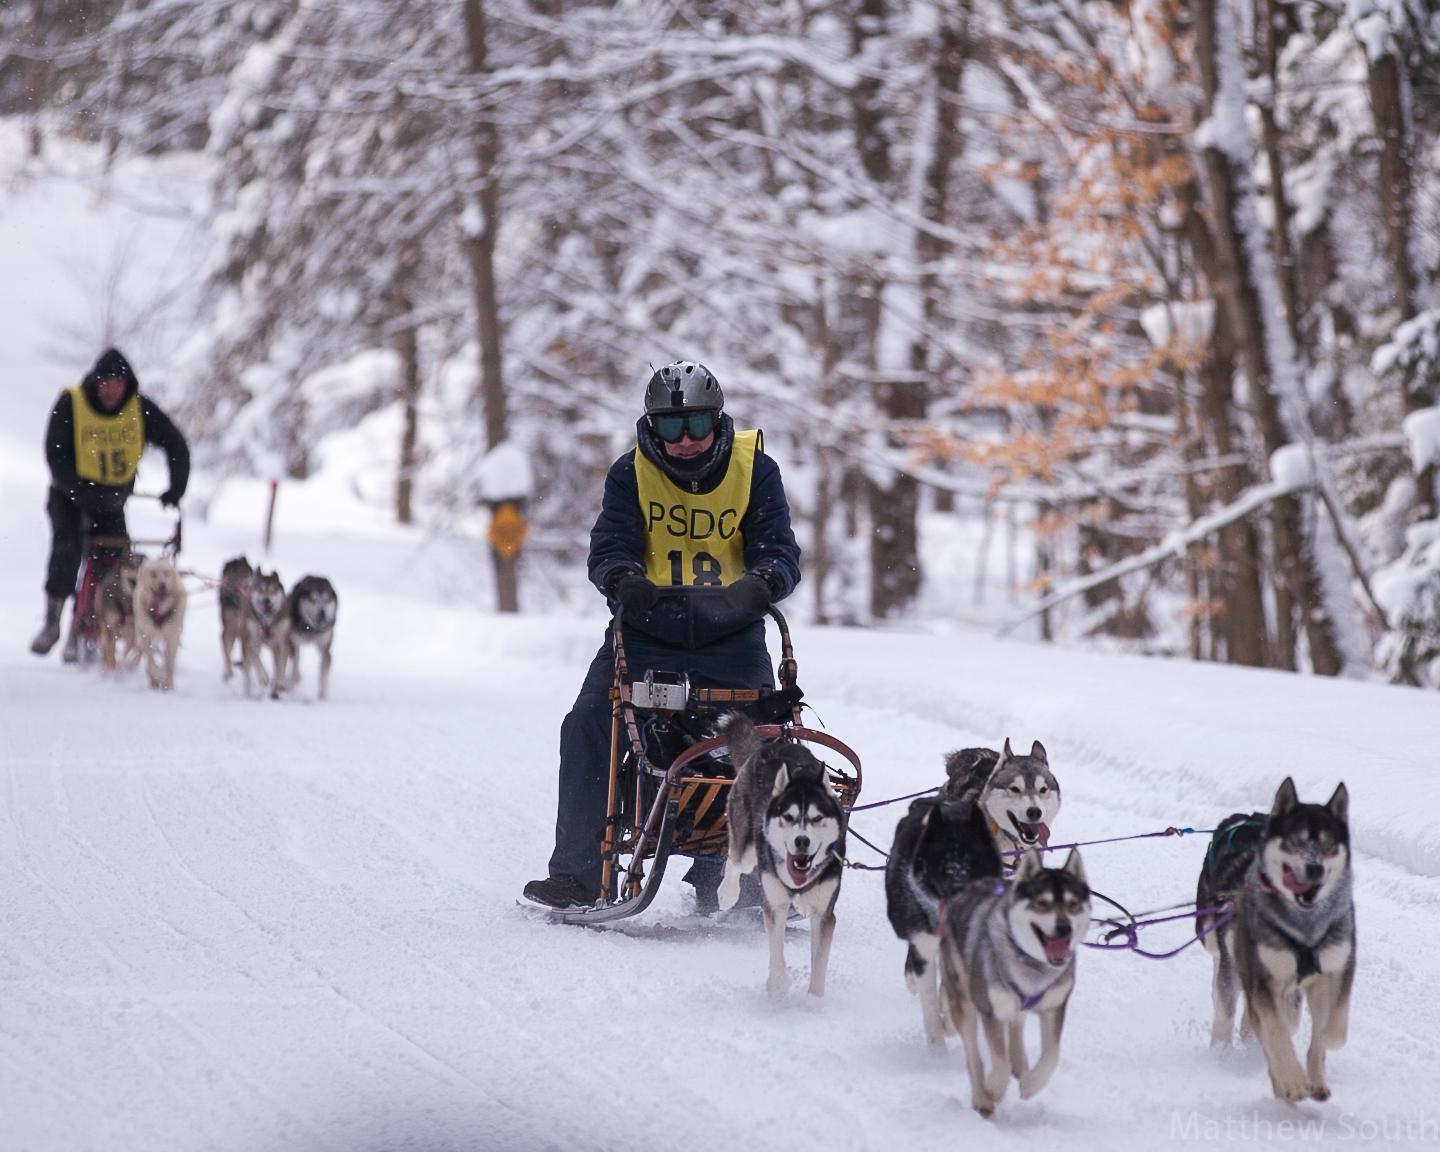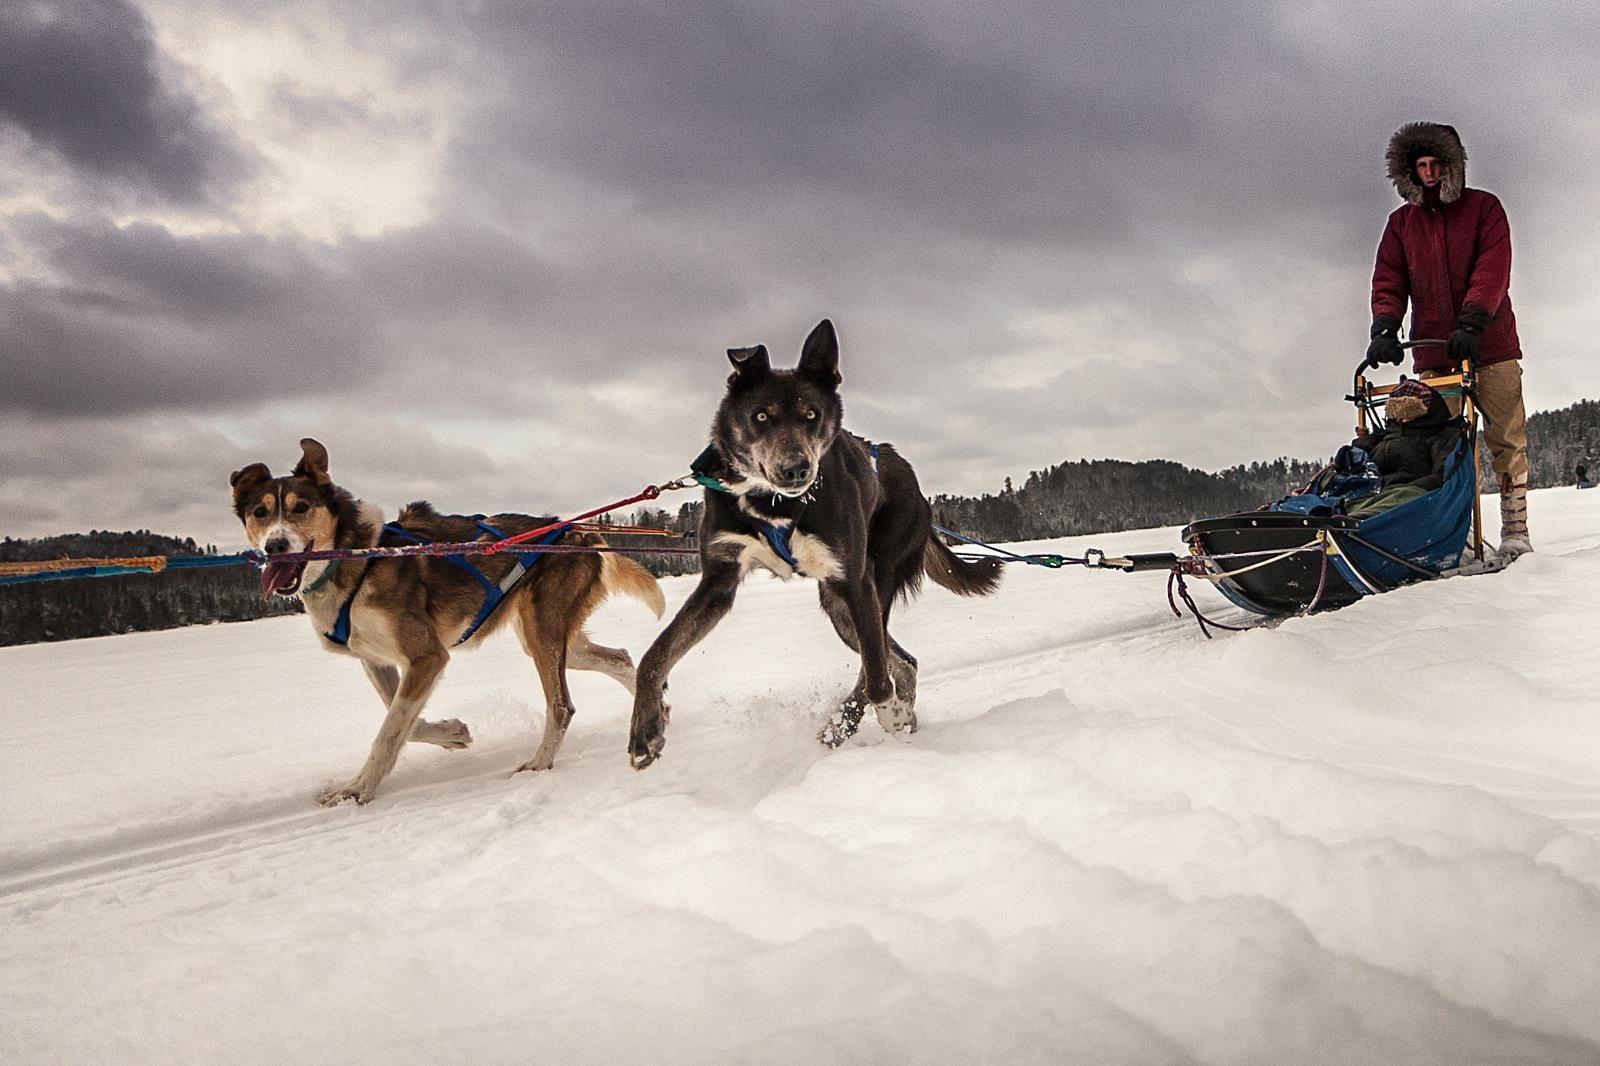The first image is the image on the left, the second image is the image on the right. Considering the images on both sides, is "One of the sleds is pulled by no more than 3 dogs." valid? Answer yes or no. Yes. 